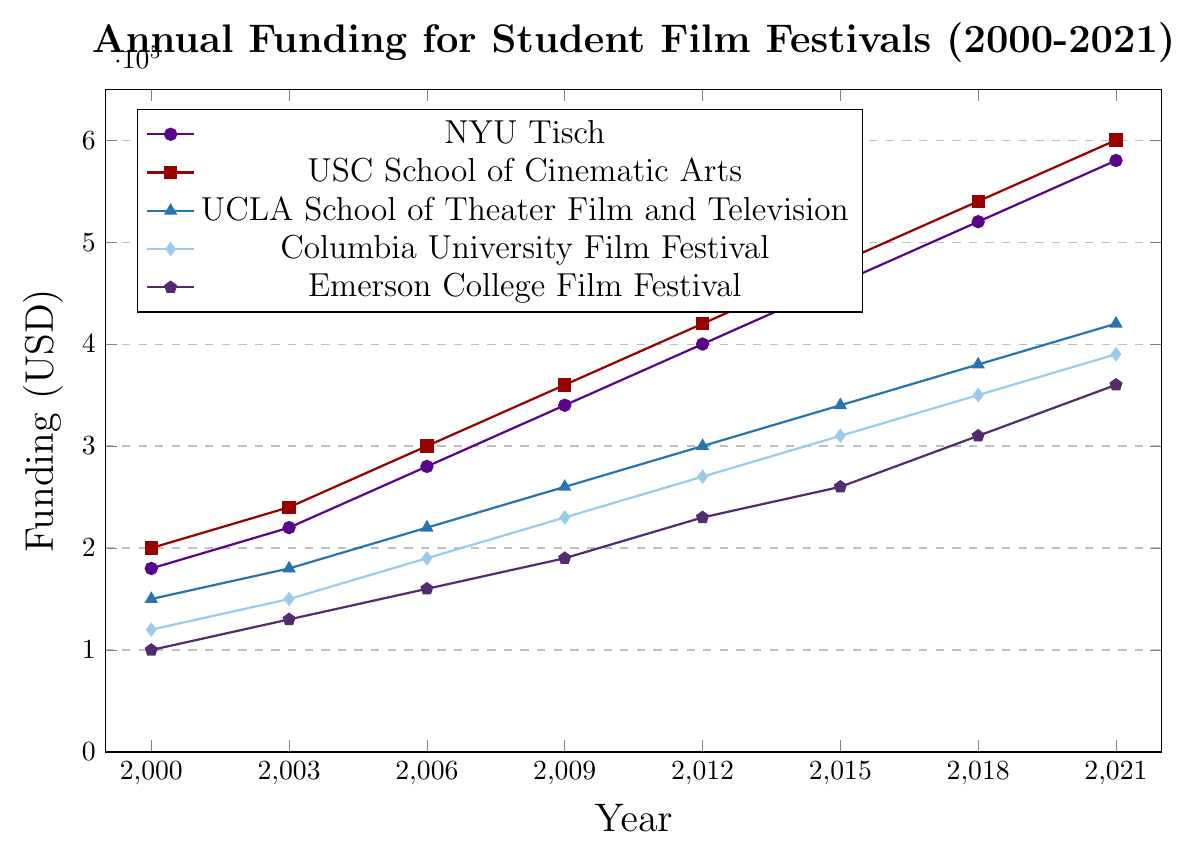What is the total increase in annual funding for NYU Tisch from 2000 to 2021? To find the total increase, subtract the funding amount in 2000 from the funding amount in 2021: 580000 - 180000 = 400000.
Answer: 400000 USD Which university received the highest funding for its student film festival in 2021? By examining the data points for 2021, the university with the highest funding amount is USC School of Cinematic Arts with 600000 USD.
Answer: USC School of Cinematic Arts How does the funding for the USC School of Cinematic Arts in 2006 compare to Columbia University Film Festival in the same year? USC School of Cinematic Arts received 300000 USD in 2006, while Columbia University Film Festival received 190000 USD. USC's funding is higher.
Answer: USC's funding was higher What is the average annual funding for Emerson College Film Festival from 2000 to 2021? To find the average, sum the funding amounts for Emerson College in the given years and divide by the number of years: (100000 + 130000 + 160000 + 190000 + 230000 + 260000 + 310000 + 360000) / 8 = 217500.
Answer: 217500 USD Between 2003 and 2009, which film festival received the most significant increase in funding? Calculate the funding increase for each film festival: NYU Tisch: 340000 - 220000 = 120000, USC: 360000 - 240000 = 120000, UCLA: 260000 - 180000 = 80000, Columbia: 230000 - 150000 = 80000, Emerson: 190000 - 130000 = 60000; USC and NYU had the most significant increase.
Answer: NYU Tisch and USC School of Cinematic Arts What is the trend of annual funding for UCLA School of Theater Film and Television from 2000 to 2021? The annual funding for UCLA increases steadily every year from 150000 USD in 2000 to 420000 USD in 2021, showing a consistent upward trend.
Answer: Upward trend In 2015, which universities had lower funding than NYU Tisch? In 2015, the funding amounts were NYU Tisch: 460000 USD, USC: 480000 USD, UCLA: 340000 USD, Columbia: 310000 USD, Emerson: 260000 USD. The universities with lower funding than NYU Tisch were UCLA, Columbia, and Emerson.
Answer: UCLA, Columbia, and Emerson How did the annual funding for the Columbia University Film Festival change from 2000 to 2018? The funding for Columbia University Film Festival increased from 120000 USD in 2000 to 350000 USD in 2018. This can be calculated as an increase of 350000 - 120000 = 230000.
Answer: Increased by 230000 USD 